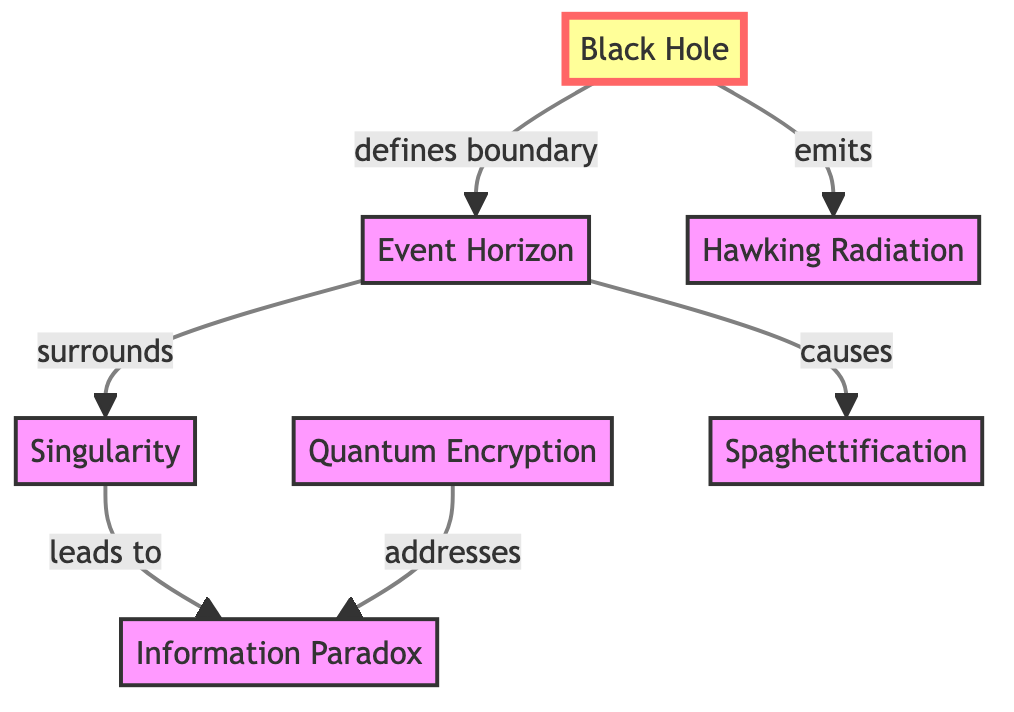What defines the boundary of a black hole? The diagram shows an arrow leading from "Black Hole" to "Event Horizon," indicating that the Event Horizon is defined as the boundary of a black hole.
Answer: Event Horizon What surrounds the singularity? The diagram demonstrates that the Event Horizon surrounds the Singularity, as indicated by the arrow from Event Horizon pointing to Singularity.
Answer: Singularity What does the black hole emit? According to the diagram, there is an arrow from "Black Hole" to "Hawking Radiation," signifying that a black hole emits Hawking Radiation.
Answer: Hawking Radiation How many nodes are connected to the event horizon? The diagram exhibits three distinct nodes that connect to the Event Horizon: the Black Hole, Singularity, and Spaghettification. Counting these connections yields three nodes.
Answer: 3 What is the relationship between event horizon and spaghettification? The diagram shows that the Event Horizon causes Spaghettification, indicated by the arrow pointing from the Event Horizon to Spaghettification.
Answer: causes What does quantum encryption address? The diagram indicates that Quantum Encryption addresses the Information Paradox, as demonstrated by the arrow connecting Quantum Encryption to Information Paradox.
Answer: Information Paradox What is the flow direction from the black hole to the event horizon? The diagram features a directional arrow from "Black Hole" to "Event Horizon," indicating that information flows from the Black Hole to the Event Horizon.
Answer: defines boundary How do singularity and information paradox relate? In the diagram, there is a direct relationship as the Singularity leads to the Information Paradox; this is indicated by the arrow from Singularity to Information Paradox.
Answer: leads to 